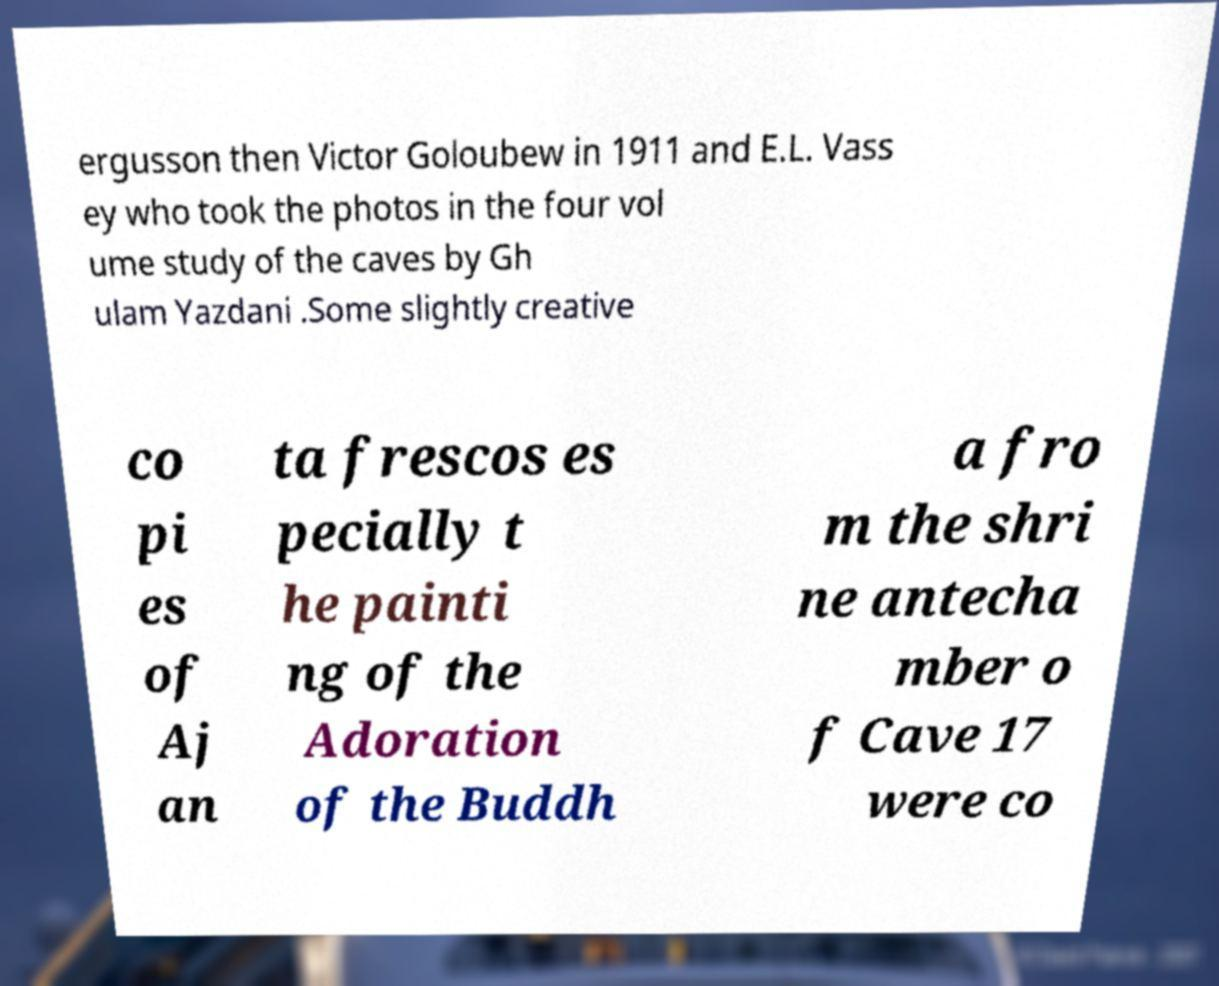For documentation purposes, I need the text within this image transcribed. Could you provide that? ergusson then Victor Goloubew in 1911 and E.L. Vass ey who took the photos in the four vol ume study of the caves by Gh ulam Yazdani .Some slightly creative co pi es of Aj an ta frescos es pecially t he painti ng of the Adoration of the Buddh a fro m the shri ne antecha mber o f Cave 17 were co 